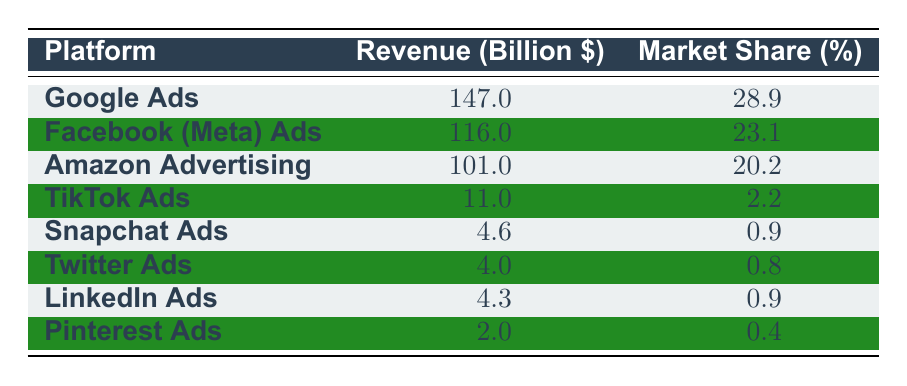What is the revenue of Google Ads? The table explicitly lists the revenue for Google Ads as 147.0 billion dollars.
Answer: 147.0 billion dollars What percentage of market share does Facebook (Meta) Ads hold? According to the table, Facebook (Meta) Ads has a market share of 23.1 percent.
Answer: 23.1 percent Which platform has the smallest revenue? By comparing all the revenue figures in the table, Pinterest Ads shows the smallest revenue at 2.0 billion dollars.
Answer: Pinterest Ads What is the total revenue of the top three platforms: Google Ads, Facebook (Meta) Ads, and Amazon Advertising? The revenues for these platforms are 147.0 billion (Google Ads), 116.0 billion (Facebook Ads), and 101.0 billion (Amazon Ads). Adding these together: 147.0 + 116.0 + 101.0 equals 364.0 billion dollars.
Answer: 364.0 billion dollars Is the market share of TikTok Ads greater than that of Twitter Ads? The table shows that TikTok Ads has a market share of 2.2 percent and Twitter Ads has 0.8 percent. Since 2.2 is greater than 0.8, TikTok Ads does have a greater market share than Twitter Ads.
Answer: Yes What is the combined market share of Snapchat Ads and LinkedIn Ads? From the table, Snapchat Ads has a market share of 0.9 percent and LinkedIn Ads also has 0.9 percent. Adding these together: 0.9 + 0.9 gives a combined market share of 1.8 percent.
Answer: 1.8 percent Are Amazon Advertising's revenues larger than those of TikTok, Snapchat, and Twitter combined? Amazon Advertising's revenue is 101.0 billion dollars. For TikTok, Snapchat, and Twitter, the revenues are 11.0 billion, 4.6 billion, and 4.0 billion, respectively. Adding these three revenues: 11.0 + 4.6 + 4.0 equals 19.6 billion dollars, which is significantly less than Amazon's 101.0 billion. Therefore, Amazon's revenue is larger.
Answer: Yes Which platform has a market share closest to 1 percent? The market shares listed are 0.4 percent for Pinterest Ads, 0.8 percent for Twitter Ads, and 0.9 percent for both Snapchat Ads and LinkedIn Ads. Since 0.9 is the closest to 1 percent, both Snapchat Ads and LinkedIn Ads share this value.
Answer: Snapchat Ads and LinkedIn Ads If the advertising revenue from TikTok and Pinterest is combined, does it exceed 15 billion dollars? The individual revenues are 11.0 billion for TikTok Ads and 2.0 billion for Pinterest Ads. Their combined revenue is 11.0 + 2.0 equals 13.0 billion dollars, which does not exceed 15 billion dollars.
Answer: No 